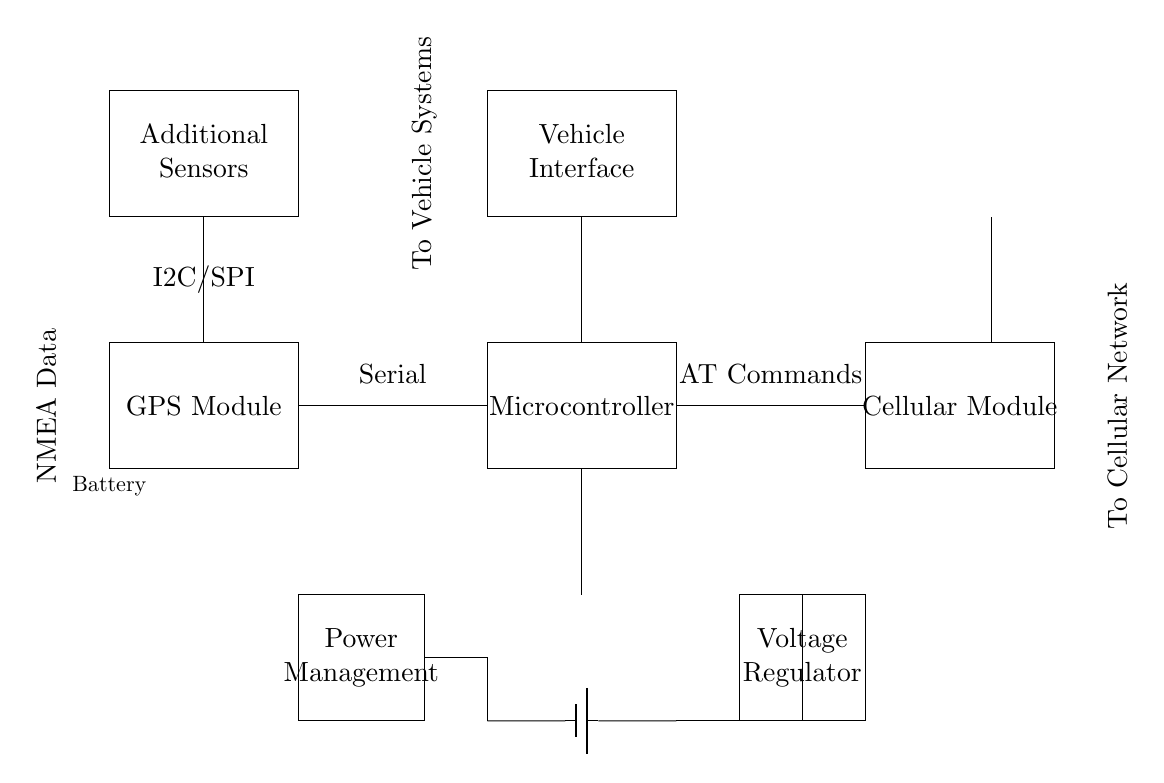What module is responsible for obtaining location data? The GPS Module is indicated as the component responsible for obtaining location data, as shown at the top left of the circuit diagram.
Answer: GPS Module What type of connection is used between the GPS Module and the Microcontroller? The connection between the GPS Module and the Microcontroller is labeled as "Serial," which suggests a serial communication method is being used for data transfer.
Answer: Serial How is the circuit powered? The circuit is powered by a Battery that is connected to the Microcontroller and Power Management unit, indicating a direct power source within the system.
Answer: Battery What is the purpose of the Voltage Regulator in this circuit? The Voltage Regulator is used to maintain a steady voltage level to various components in the circuit, ensuring they operate within their specified range and preventing damage from voltage fluctuations.
Answer: Voltage Regulator How do the Additional Sensors communicate with the Microcontroller? The Additional Sensors communicate with the Microcontroller using I2C/SPI, which is shown as a label connecting the sensors to the Microcontroller. This implies a communication protocol designed for interfacing multiple sensors.
Answer: I2C/SPI Which component connects the circuit to the cellular network? The Cellular Module is the component that connects the circuit to the cellular network, as indicated in the diagram, thereby allowing for remote communication and data transmission.
Answer: Cellular Module What type of interface is described by "Vehicle Interface"? The Vehicle Interface is likely designed to connect and interact with the vehicle's systems, allowing for integration with existing vehicle technology to provide telemetry data and control options.
Answer: Vehicle Interface 